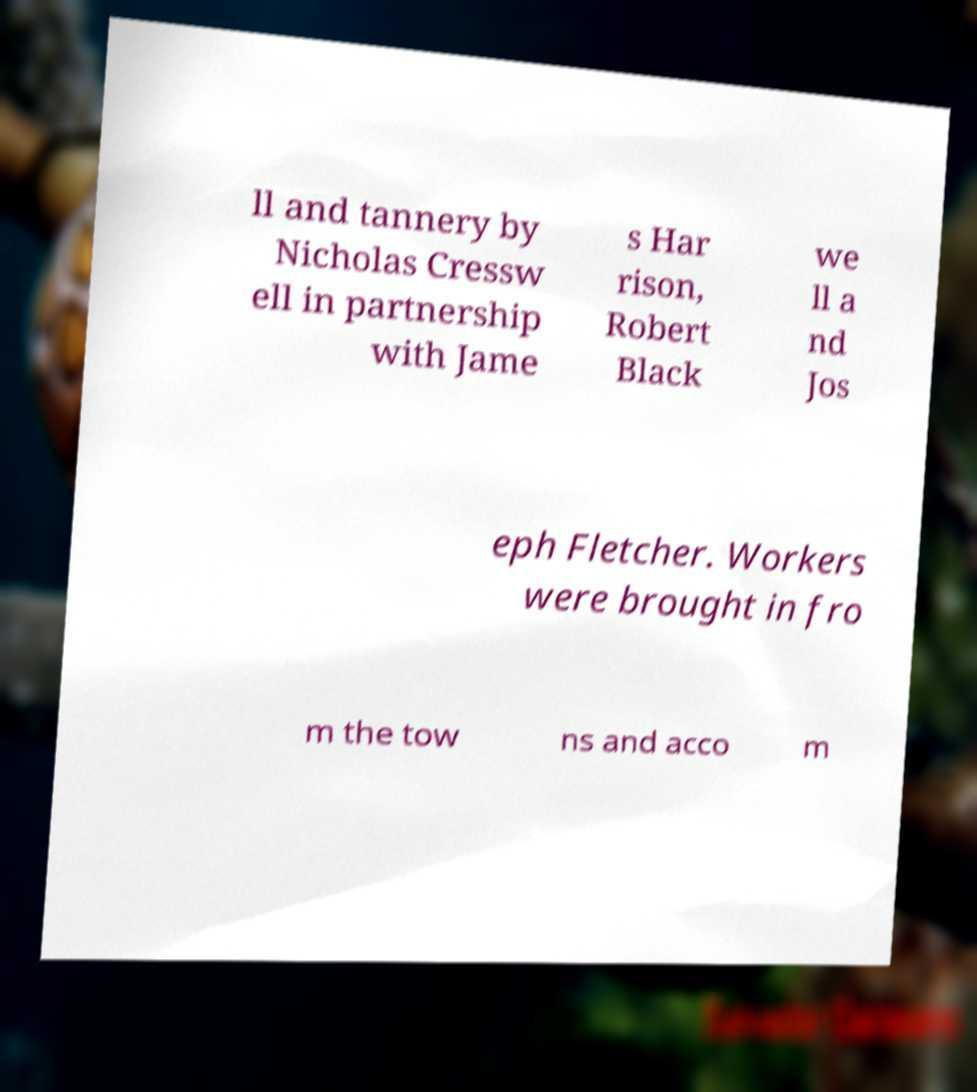Please identify and transcribe the text found in this image. ll and tannery by Nicholas Cressw ell in partnership with Jame s Har rison, Robert Black we ll a nd Jos eph Fletcher. Workers were brought in fro m the tow ns and acco m 